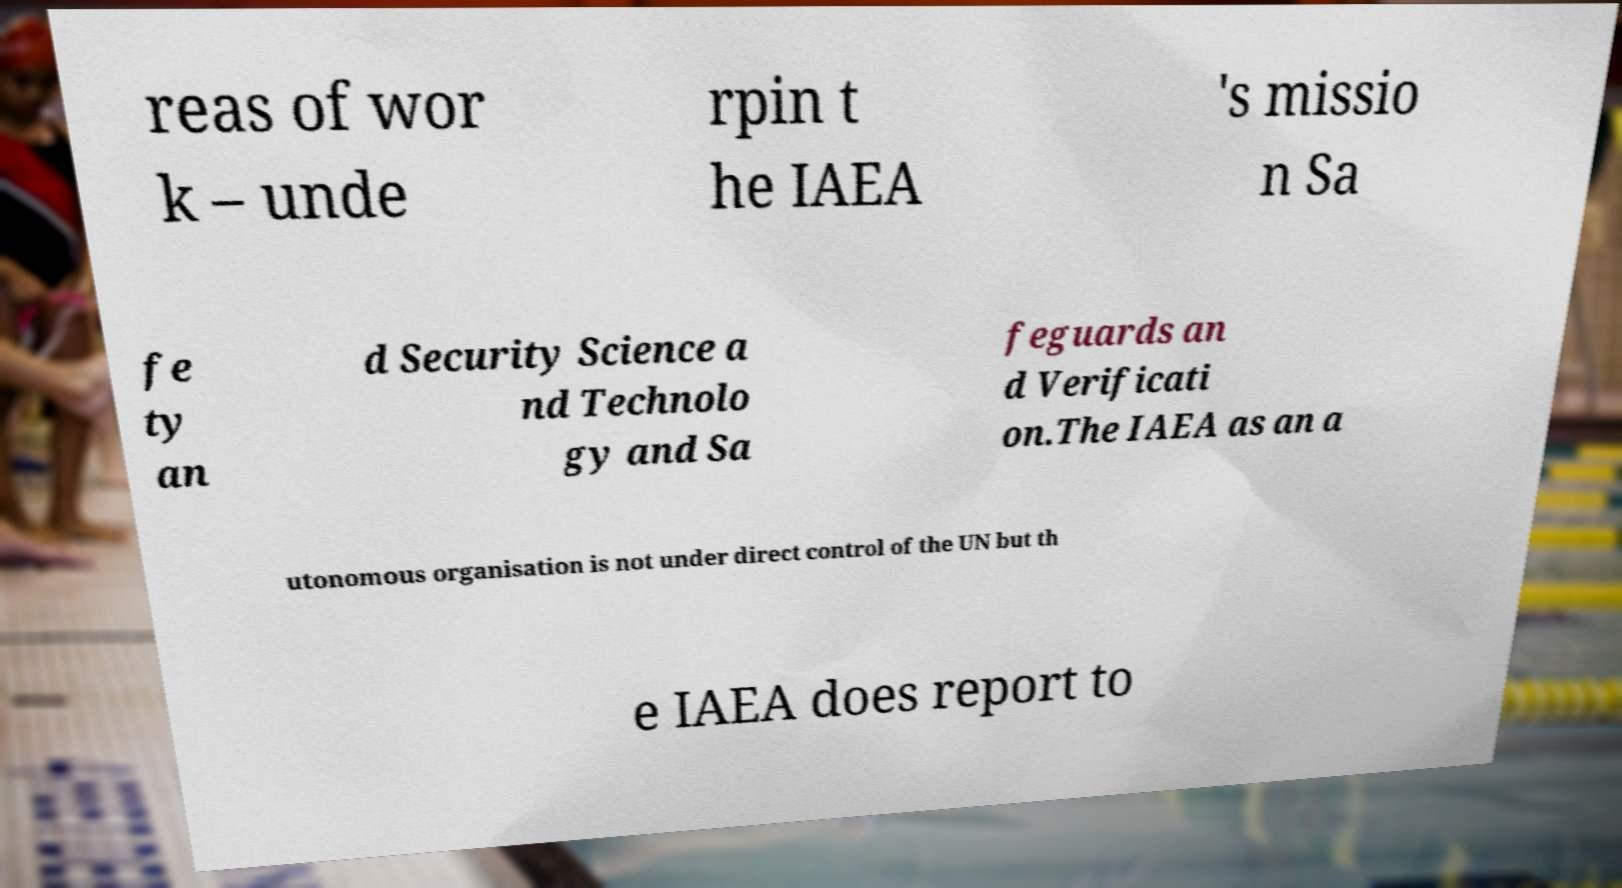I need the written content from this picture converted into text. Can you do that? reas of wor k – unde rpin t he IAEA 's missio n Sa fe ty an d Security Science a nd Technolo gy and Sa feguards an d Verificati on.The IAEA as an a utonomous organisation is not under direct control of the UN but th e IAEA does report to 